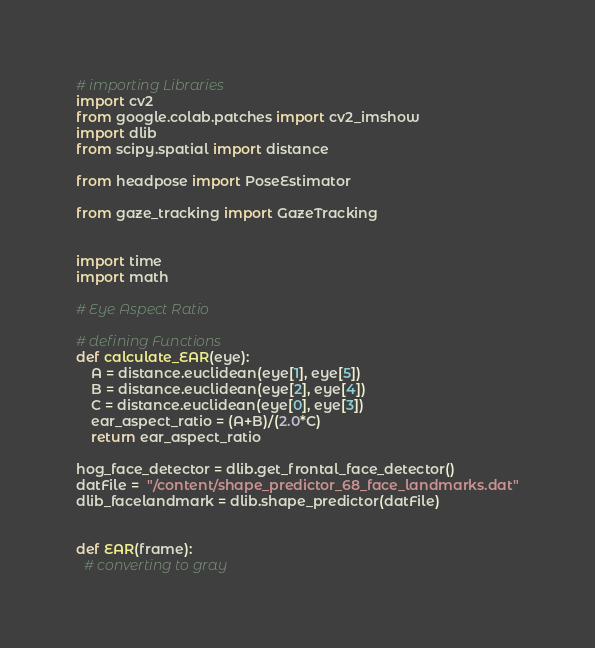Convert code to text. <code><loc_0><loc_0><loc_500><loc_500><_Python_># importing Libraries
import cv2
from google.colab.patches import cv2_imshow
import dlib
from scipy.spatial import distance

from headpose import PoseEstimator

from gaze_tracking import GazeTracking


import time
import math

# Eye Aspect Ratio

# defining Functions
def calculate_EAR(eye):
	A = distance.euclidean(eye[1], eye[5])
	B = distance.euclidean(eye[2], eye[4])
	C = distance.euclidean(eye[0], eye[3])
	ear_aspect_ratio = (A+B)/(2.0*C)
	return ear_aspect_ratio

hog_face_detector = dlib.get_frontal_face_detector()
datFile =  "/content/shape_predictor_68_face_landmarks.dat"
dlib_facelandmark = dlib.shape_predictor(datFile)


def EAR(frame):
  # converting to gray</code> 